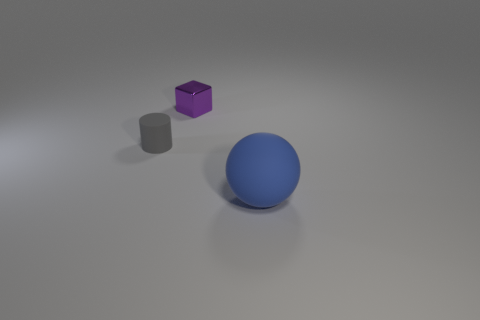Add 3 yellow shiny balls. How many objects exist? 6 Subtract all cylinders. How many objects are left? 2 Add 2 big blue matte spheres. How many big blue matte spheres are left? 3 Add 1 large blue blocks. How many large blue blocks exist? 1 Subtract 0 brown cylinders. How many objects are left? 3 Subtract all big gray things. Subtract all gray matte things. How many objects are left? 2 